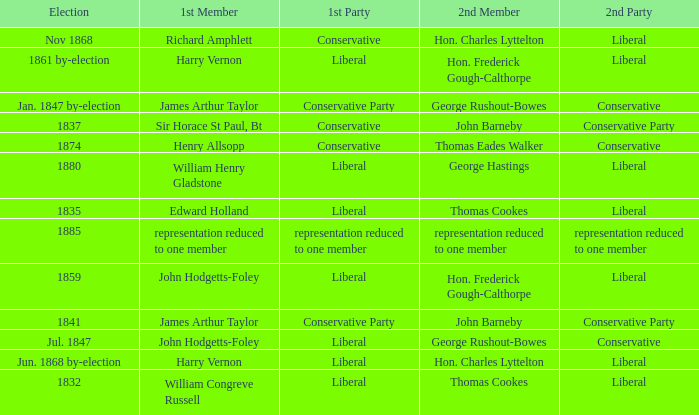What was the 2nd Party when its 2nd Member was George Rushout-Bowes, and the 1st Party was Liberal? Conservative. 